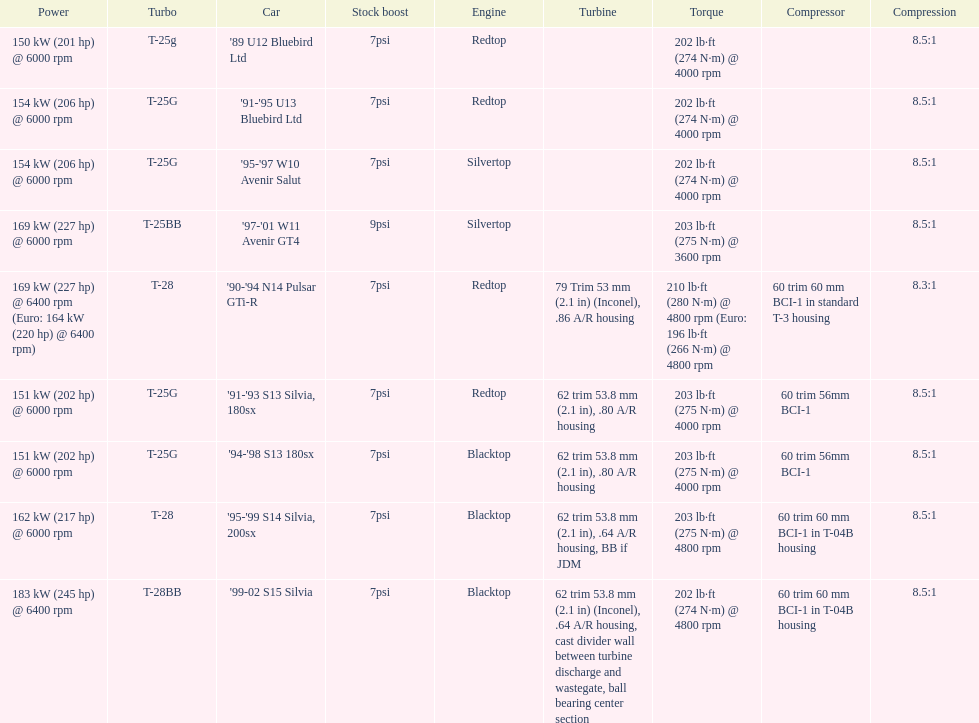Which engine has the smallest compression rate? '90-'94 N14 Pulsar GTi-R. 